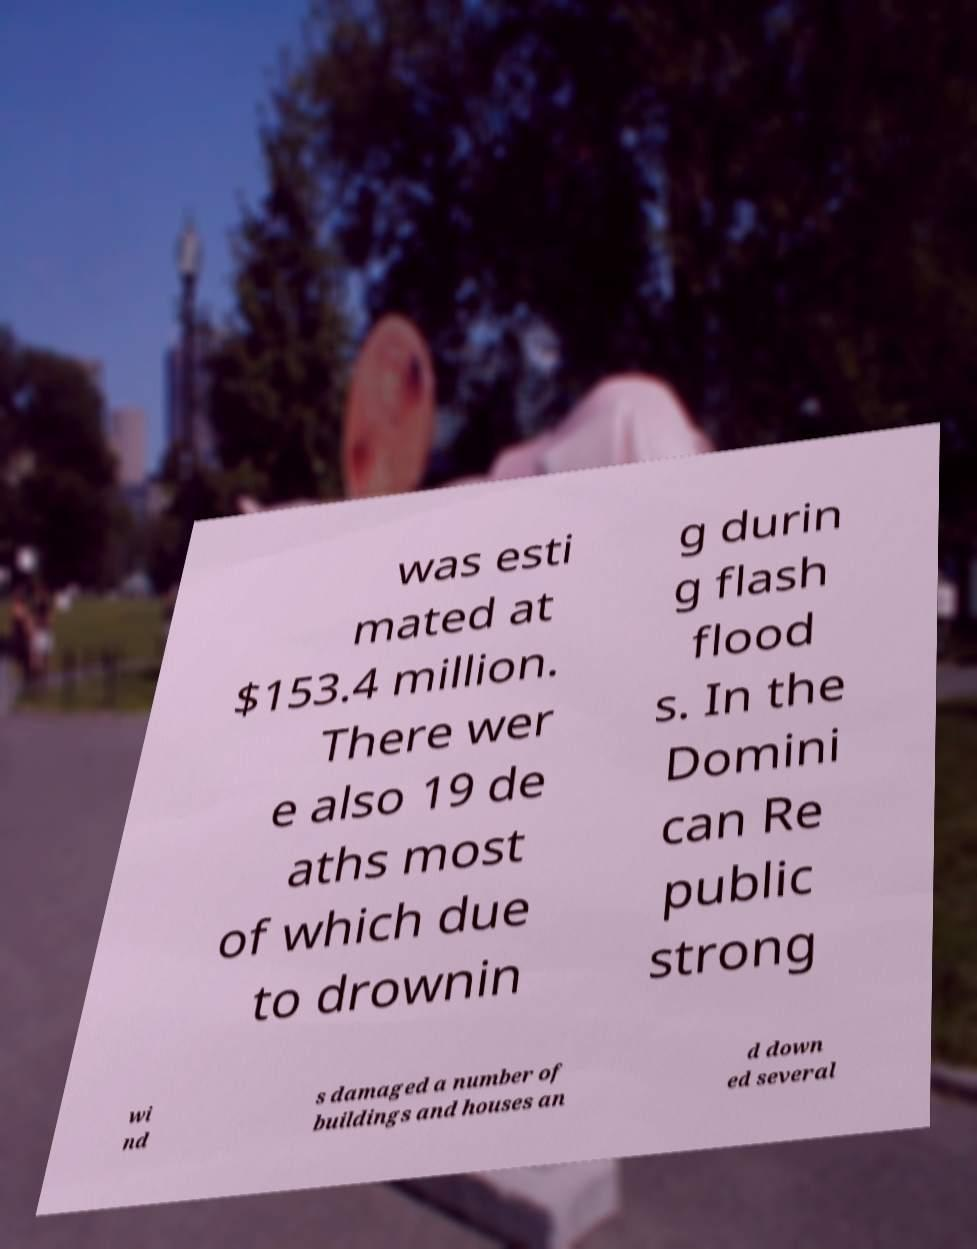What messages or text are displayed in this image? I need them in a readable, typed format. was esti mated at $153.4 million. There wer e also 19 de aths most of which due to drownin g durin g flash flood s. In the Domini can Re public strong wi nd s damaged a number of buildings and houses an d down ed several 